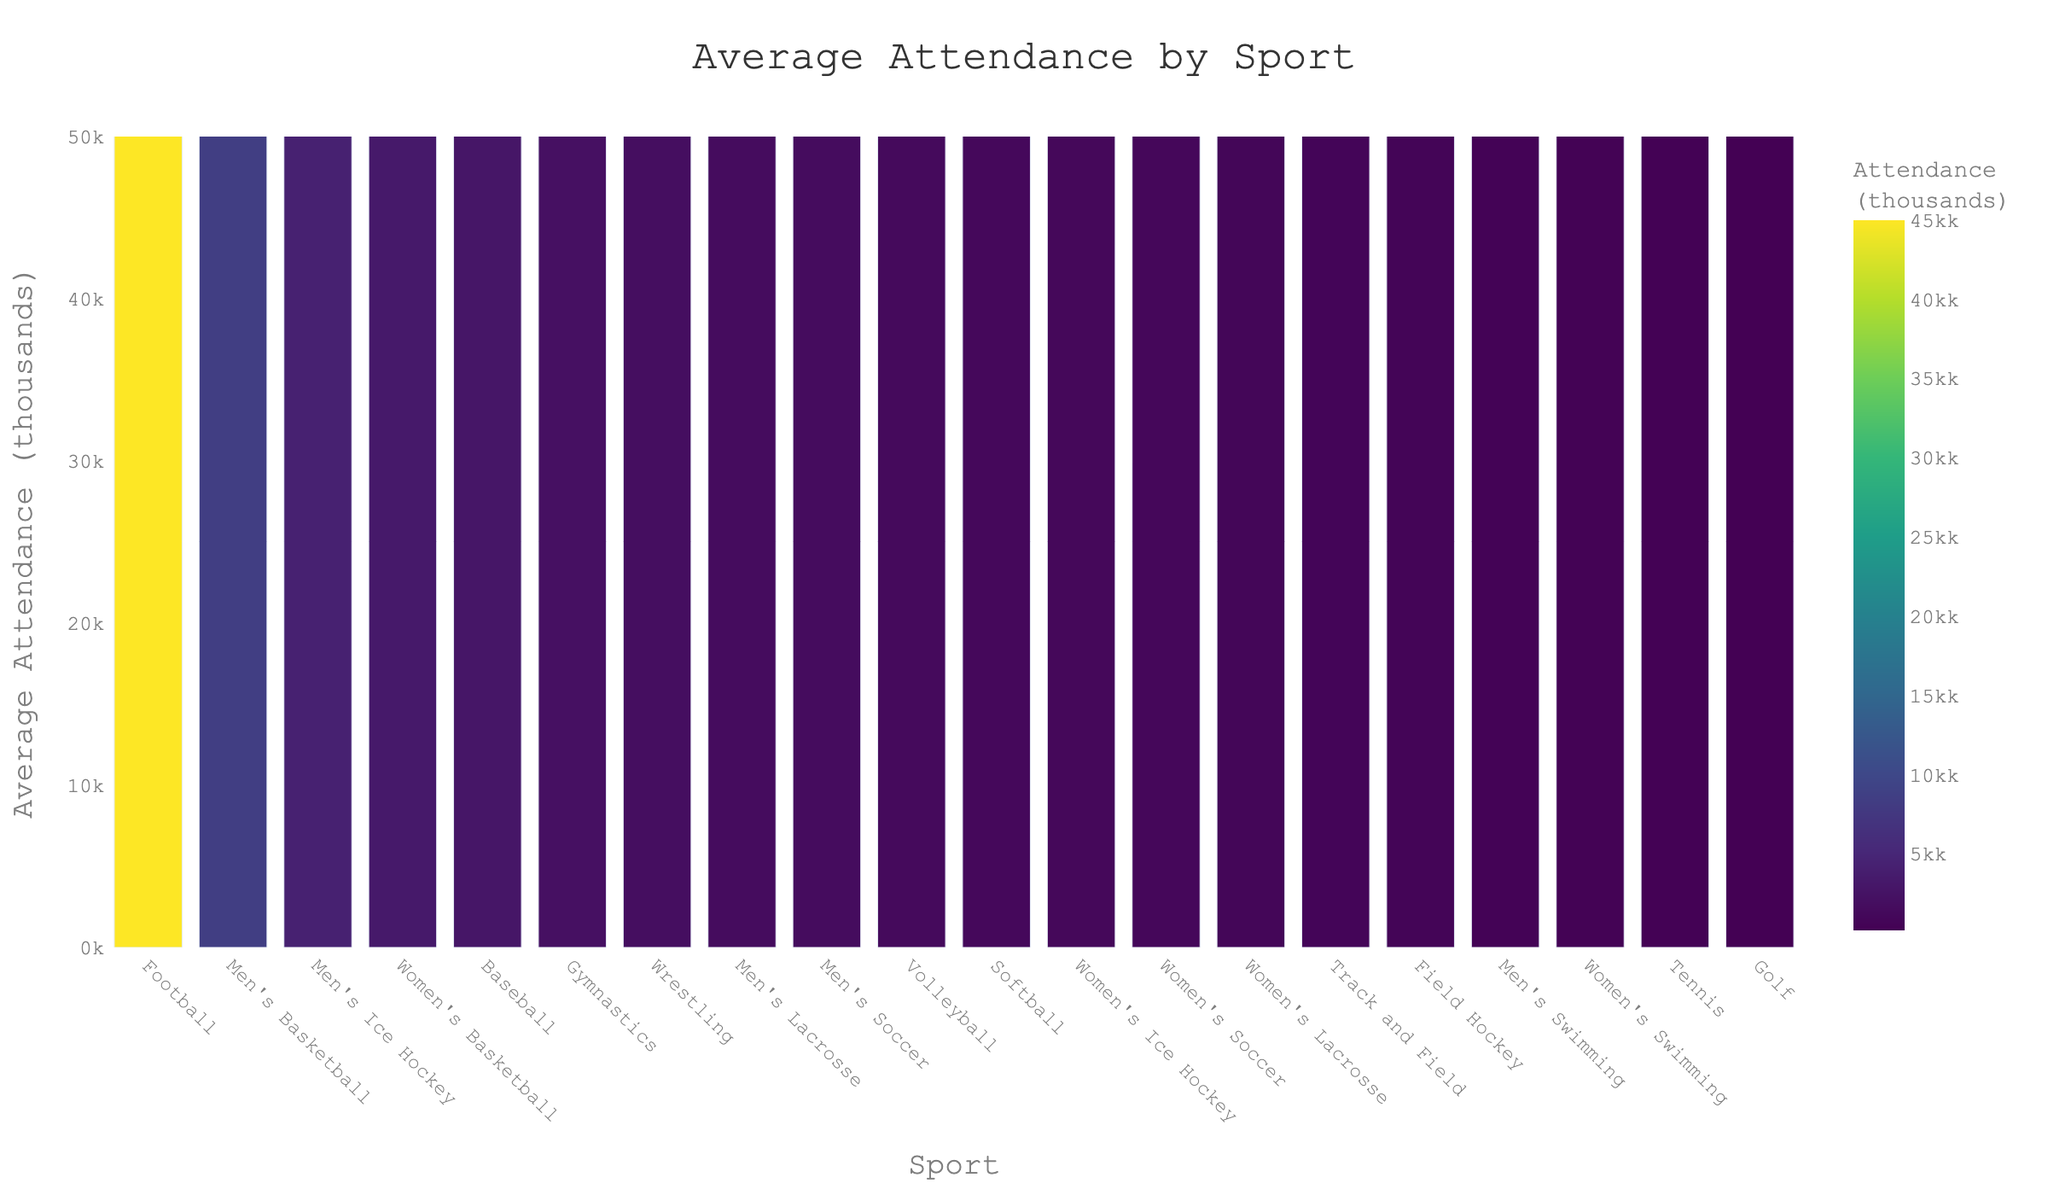How does the attendance for Football compare to Men's Basketball? Football has an average attendance of 45,000, while Men's Basketball has an average attendance of 8,500. Comparing these, Football has significantly higher attendance. To find the exact difference: 45,000 - 8,500 = 36,500 more attendees for Football.
Answer: 36,500 more for Football Which sport has the lowest average attendance? In the figure, Tennis and Golf appear to have the shortest bars, indicating the lowest attendance numbers. Between the two, Golf has the smallest bar. Therefore, Golf has the lowest average attendance.
Answer: Golf What's the combined average attendance for Women's Basketball, Baseball, and Men's Soccer? Women's Basketball has 3,200, Baseball has 2,800, and Men's Soccer has 1,500 attendees. Summing these numbers gives: 3,200 + 2,800 + 1,500 = 7,500.
Answer: 7,500 Is there a sport where the women's team has higher attendance than the men's team? By comparing sports with both men's and women's figures, we see the bars for Men's and Women's Soccer and Men's and Women's Ice Hockey. Men's attendance is higher in both cases. Therefore, there is no sport where the women's team has higher attendance than the men's team.
Answer: No What is the difference in average attendance between Men's Ice Hockey and Volleyball? Men's Ice Hockey has an average attendance of 4,200, while Volleyball has 1,300. Subtracting these figures gives: 4,200 - 1,300 = 2,900.
Answer: 2,900 What is the total average attendance for revenue-generating sports (Football and Men's Basketball)? Football has 45,000 and Men's Basketball has 8,500 attendees. Adding these values gives: 45,000 + 8,500 = 53,500.
Answer: 53,500 What's the ratio of average attendance of Softball to Wrestling? Softball has 1,100 and Wrestling has 1,800 attendees. Dividing these gives: 1,100 / 1,800 ≈ 0.61.
Answer: ~0.61 Which sport shows the largest range in average attendance among the listed ones? The largest range would come from comparing the highest and lowest attendance values. Football has the highest at 45,000, and Golf has the lowest at 150. The range is: 45,000 - 150 = 44,850.
Answer: Football with a range of 44,850 What is the average attendance of all sports combined? To find the average, sum all attendance values and divide by the number of sports: (45,000 + 8,500 + 3,200 + 2,800 + 1,100 + 1,500 + 950 + 1,300 + 4,200 + 1,000 + 1,800 + 2,100 + 1,600 + 750 + 600 + 400 + 350 + 700 + 250 + 150) / 20 = 77,450 / 20 = 3,872.5.
Answer: 3,872.5 